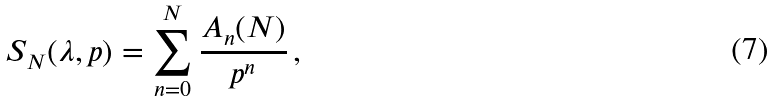Convert formula to latex. <formula><loc_0><loc_0><loc_500><loc_500>S _ { N } ( \lambda , p ) = \sum _ { n = 0 } ^ { N } { \frac { A _ { n } ( N ) } { p ^ { n } } } \, ,</formula> 